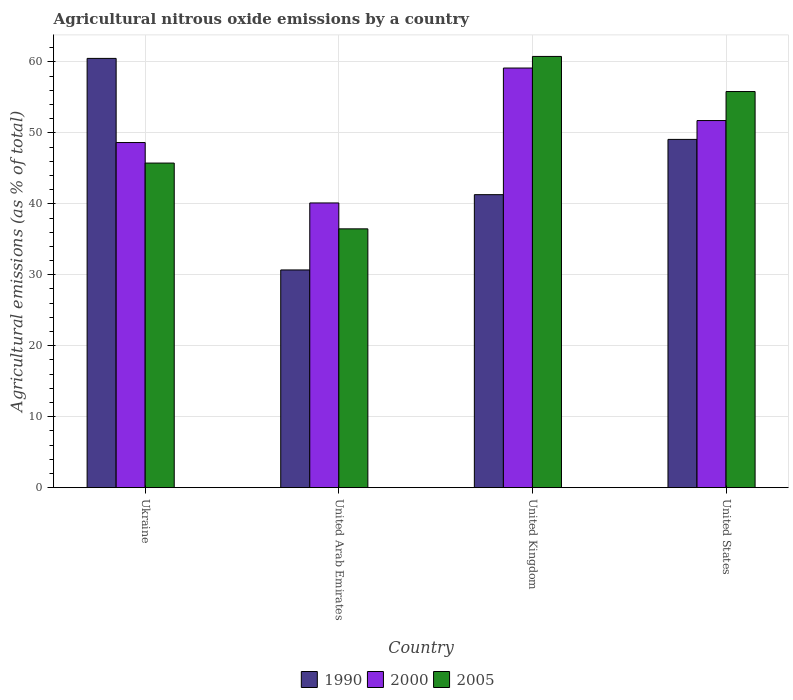How many different coloured bars are there?
Give a very brief answer. 3. How many groups of bars are there?
Keep it short and to the point. 4. Are the number of bars on each tick of the X-axis equal?
Give a very brief answer. Yes. What is the label of the 2nd group of bars from the left?
Offer a terse response. United Arab Emirates. What is the amount of agricultural nitrous oxide emitted in 2005 in United States?
Your response must be concise. 55.83. Across all countries, what is the maximum amount of agricultural nitrous oxide emitted in 1990?
Ensure brevity in your answer.  60.5. Across all countries, what is the minimum amount of agricultural nitrous oxide emitted in 2005?
Keep it short and to the point. 36.47. In which country was the amount of agricultural nitrous oxide emitted in 1990 minimum?
Give a very brief answer. United Arab Emirates. What is the total amount of agricultural nitrous oxide emitted in 2000 in the graph?
Ensure brevity in your answer.  199.64. What is the difference between the amount of agricultural nitrous oxide emitted in 2005 in Ukraine and that in United Kingdom?
Offer a terse response. -15.03. What is the difference between the amount of agricultural nitrous oxide emitted in 1990 in United Kingdom and the amount of agricultural nitrous oxide emitted in 2000 in United States?
Make the answer very short. -10.45. What is the average amount of agricultural nitrous oxide emitted in 1990 per country?
Your answer should be very brief. 45.39. What is the difference between the amount of agricultural nitrous oxide emitted of/in 2000 and amount of agricultural nitrous oxide emitted of/in 2005 in United States?
Keep it short and to the point. -4.09. In how many countries, is the amount of agricultural nitrous oxide emitted in 2005 greater than 6 %?
Your answer should be compact. 4. What is the ratio of the amount of agricultural nitrous oxide emitted in 1990 in Ukraine to that in United States?
Give a very brief answer. 1.23. What is the difference between the highest and the second highest amount of agricultural nitrous oxide emitted in 2000?
Give a very brief answer. -3.1. What is the difference between the highest and the lowest amount of agricultural nitrous oxide emitted in 2005?
Ensure brevity in your answer.  24.3. In how many countries, is the amount of agricultural nitrous oxide emitted in 2000 greater than the average amount of agricultural nitrous oxide emitted in 2000 taken over all countries?
Give a very brief answer. 2. Is the sum of the amount of agricultural nitrous oxide emitted in 2000 in Ukraine and United Arab Emirates greater than the maximum amount of agricultural nitrous oxide emitted in 2005 across all countries?
Make the answer very short. Yes. What does the 3rd bar from the left in United Kingdom represents?
Your response must be concise. 2005. Is it the case that in every country, the sum of the amount of agricultural nitrous oxide emitted in 1990 and amount of agricultural nitrous oxide emitted in 2000 is greater than the amount of agricultural nitrous oxide emitted in 2005?
Provide a short and direct response. Yes. How many bars are there?
Your answer should be compact. 12. How many countries are there in the graph?
Give a very brief answer. 4. What is the difference between two consecutive major ticks on the Y-axis?
Offer a very short reply. 10. Does the graph contain any zero values?
Provide a short and direct response. No. Does the graph contain grids?
Provide a succinct answer. Yes. Where does the legend appear in the graph?
Make the answer very short. Bottom center. How many legend labels are there?
Your answer should be very brief. 3. What is the title of the graph?
Offer a very short reply. Agricultural nitrous oxide emissions by a country. Does "2003" appear as one of the legend labels in the graph?
Provide a succinct answer. No. What is the label or title of the X-axis?
Keep it short and to the point. Country. What is the label or title of the Y-axis?
Offer a very short reply. Agricultural emissions (as % of total). What is the Agricultural emissions (as % of total) of 1990 in Ukraine?
Ensure brevity in your answer.  60.5. What is the Agricultural emissions (as % of total) of 2000 in Ukraine?
Keep it short and to the point. 48.64. What is the Agricultural emissions (as % of total) in 2005 in Ukraine?
Your response must be concise. 45.75. What is the Agricultural emissions (as % of total) in 1990 in United Arab Emirates?
Keep it short and to the point. 30.68. What is the Agricultural emissions (as % of total) of 2000 in United Arab Emirates?
Keep it short and to the point. 40.12. What is the Agricultural emissions (as % of total) of 2005 in United Arab Emirates?
Make the answer very short. 36.47. What is the Agricultural emissions (as % of total) of 1990 in United Kingdom?
Make the answer very short. 41.29. What is the Agricultural emissions (as % of total) in 2000 in United Kingdom?
Offer a very short reply. 59.14. What is the Agricultural emissions (as % of total) in 2005 in United Kingdom?
Provide a succinct answer. 60.77. What is the Agricultural emissions (as % of total) in 1990 in United States?
Your answer should be compact. 49.08. What is the Agricultural emissions (as % of total) of 2000 in United States?
Give a very brief answer. 51.74. What is the Agricultural emissions (as % of total) of 2005 in United States?
Your answer should be very brief. 55.83. Across all countries, what is the maximum Agricultural emissions (as % of total) in 1990?
Offer a terse response. 60.5. Across all countries, what is the maximum Agricultural emissions (as % of total) in 2000?
Provide a short and direct response. 59.14. Across all countries, what is the maximum Agricultural emissions (as % of total) in 2005?
Provide a short and direct response. 60.77. Across all countries, what is the minimum Agricultural emissions (as % of total) of 1990?
Provide a succinct answer. 30.68. Across all countries, what is the minimum Agricultural emissions (as % of total) in 2000?
Keep it short and to the point. 40.12. Across all countries, what is the minimum Agricultural emissions (as % of total) of 2005?
Keep it short and to the point. 36.47. What is the total Agricultural emissions (as % of total) of 1990 in the graph?
Provide a short and direct response. 181.55. What is the total Agricultural emissions (as % of total) of 2000 in the graph?
Your answer should be compact. 199.64. What is the total Agricultural emissions (as % of total) of 2005 in the graph?
Make the answer very short. 198.82. What is the difference between the Agricultural emissions (as % of total) in 1990 in Ukraine and that in United Arab Emirates?
Make the answer very short. 29.81. What is the difference between the Agricultural emissions (as % of total) of 2000 in Ukraine and that in United Arab Emirates?
Your answer should be compact. 8.51. What is the difference between the Agricultural emissions (as % of total) in 2005 in Ukraine and that in United Arab Emirates?
Your answer should be compact. 9.27. What is the difference between the Agricultural emissions (as % of total) in 1990 in Ukraine and that in United Kingdom?
Provide a succinct answer. 19.2. What is the difference between the Agricultural emissions (as % of total) in 2000 in Ukraine and that in United Kingdom?
Give a very brief answer. -10.5. What is the difference between the Agricultural emissions (as % of total) in 2005 in Ukraine and that in United Kingdom?
Give a very brief answer. -15.03. What is the difference between the Agricultural emissions (as % of total) in 1990 in Ukraine and that in United States?
Provide a succinct answer. 11.42. What is the difference between the Agricultural emissions (as % of total) in 2000 in Ukraine and that in United States?
Offer a terse response. -3.1. What is the difference between the Agricultural emissions (as % of total) of 2005 in Ukraine and that in United States?
Keep it short and to the point. -10.08. What is the difference between the Agricultural emissions (as % of total) in 1990 in United Arab Emirates and that in United Kingdom?
Give a very brief answer. -10.61. What is the difference between the Agricultural emissions (as % of total) in 2000 in United Arab Emirates and that in United Kingdom?
Ensure brevity in your answer.  -19.01. What is the difference between the Agricultural emissions (as % of total) in 2005 in United Arab Emirates and that in United Kingdom?
Offer a very short reply. -24.3. What is the difference between the Agricultural emissions (as % of total) in 1990 in United Arab Emirates and that in United States?
Your response must be concise. -18.4. What is the difference between the Agricultural emissions (as % of total) in 2000 in United Arab Emirates and that in United States?
Your response must be concise. -11.61. What is the difference between the Agricultural emissions (as % of total) of 2005 in United Arab Emirates and that in United States?
Provide a short and direct response. -19.35. What is the difference between the Agricultural emissions (as % of total) of 1990 in United Kingdom and that in United States?
Offer a terse response. -7.79. What is the difference between the Agricultural emissions (as % of total) of 2000 in United Kingdom and that in United States?
Provide a succinct answer. 7.4. What is the difference between the Agricultural emissions (as % of total) of 2005 in United Kingdom and that in United States?
Offer a terse response. 4.95. What is the difference between the Agricultural emissions (as % of total) in 1990 in Ukraine and the Agricultural emissions (as % of total) in 2000 in United Arab Emirates?
Your response must be concise. 20.37. What is the difference between the Agricultural emissions (as % of total) of 1990 in Ukraine and the Agricultural emissions (as % of total) of 2005 in United Arab Emirates?
Keep it short and to the point. 24.02. What is the difference between the Agricultural emissions (as % of total) of 2000 in Ukraine and the Agricultural emissions (as % of total) of 2005 in United Arab Emirates?
Give a very brief answer. 12.16. What is the difference between the Agricultural emissions (as % of total) of 1990 in Ukraine and the Agricultural emissions (as % of total) of 2000 in United Kingdom?
Offer a terse response. 1.36. What is the difference between the Agricultural emissions (as % of total) in 1990 in Ukraine and the Agricultural emissions (as % of total) in 2005 in United Kingdom?
Keep it short and to the point. -0.28. What is the difference between the Agricultural emissions (as % of total) in 2000 in Ukraine and the Agricultural emissions (as % of total) in 2005 in United Kingdom?
Provide a succinct answer. -12.14. What is the difference between the Agricultural emissions (as % of total) of 1990 in Ukraine and the Agricultural emissions (as % of total) of 2000 in United States?
Your answer should be compact. 8.76. What is the difference between the Agricultural emissions (as % of total) of 1990 in Ukraine and the Agricultural emissions (as % of total) of 2005 in United States?
Your response must be concise. 4.67. What is the difference between the Agricultural emissions (as % of total) in 2000 in Ukraine and the Agricultural emissions (as % of total) in 2005 in United States?
Your answer should be very brief. -7.19. What is the difference between the Agricultural emissions (as % of total) in 1990 in United Arab Emirates and the Agricultural emissions (as % of total) in 2000 in United Kingdom?
Provide a short and direct response. -28.46. What is the difference between the Agricultural emissions (as % of total) of 1990 in United Arab Emirates and the Agricultural emissions (as % of total) of 2005 in United Kingdom?
Your answer should be very brief. -30.09. What is the difference between the Agricultural emissions (as % of total) of 2000 in United Arab Emirates and the Agricultural emissions (as % of total) of 2005 in United Kingdom?
Your answer should be compact. -20.65. What is the difference between the Agricultural emissions (as % of total) of 1990 in United Arab Emirates and the Agricultural emissions (as % of total) of 2000 in United States?
Ensure brevity in your answer.  -21.05. What is the difference between the Agricultural emissions (as % of total) of 1990 in United Arab Emirates and the Agricultural emissions (as % of total) of 2005 in United States?
Provide a succinct answer. -25.14. What is the difference between the Agricultural emissions (as % of total) of 2000 in United Arab Emirates and the Agricultural emissions (as % of total) of 2005 in United States?
Offer a very short reply. -15.7. What is the difference between the Agricultural emissions (as % of total) in 1990 in United Kingdom and the Agricultural emissions (as % of total) in 2000 in United States?
Your response must be concise. -10.45. What is the difference between the Agricultural emissions (as % of total) of 1990 in United Kingdom and the Agricultural emissions (as % of total) of 2005 in United States?
Provide a short and direct response. -14.53. What is the difference between the Agricultural emissions (as % of total) in 2000 in United Kingdom and the Agricultural emissions (as % of total) in 2005 in United States?
Offer a very short reply. 3.31. What is the average Agricultural emissions (as % of total) in 1990 per country?
Provide a succinct answer. 45.39. What is the average Agricultural emissions (as % of total) in 2000 per country?
Make the answer very short. 49.91. What is the average Agricultural emissions (as % of total) of 2005 per country?
Provide a short and direct response. 49.7. What is the difference between the Agricultural emissions (as % of total) of 1990 and Agricultural emissions (as % of total) of 2000 in Ukraine?
Your answer should be very brief. 11.86. What is the difference between the Agricultural emissions (as % of total) of 1990 and Agricultural emissions (as % of total) of 2005 in Ukraine?
Your answer should be very brief. 14.75. What is the difference between the Agricultural emissions (as % of total) of 2000 and Agricultural emissions (as % of total) of 2005 in Ukraine?
Your answer should be compact. 2.89. What is the difference between the Agricultural emissions (as % of total) of 1990 and Agricultural emissions (as % of total) of 2000 in United Arab Emirates?
Keep it short and to the point. -9.44. What is the difference between the Agricultural emissions (as % of total) in 1990 and Agricultural emissions (as % of total) in 2005 in United Arab Emirates?
Offer a terse response. -5.79. What is the difference between the Agricultural emissions (as % of total) in 2000 and Agricultural emissions (as % of total) in 2005 in United Arab Emirates?
Offer a terse response. 3.65. What is the difference between the Agricultural emissions (as % of total) in 1990 and Agricultural emissions (as % of total) in 2000 in United Kingdom?
Keep it short and to the point. -17.85. What is the difference between the Agricultural emissions (as % of total) in 1990 and Agricultural emissions (as % of total) in 2005 in United Kingdom?
Make the answer very short. -19.48. What is the difference between the Agricultural emissions (as % of total) in 2000 and Agricultural emissions (as % of total) in 2005 in United Kingdom?
Offer a very short reply. -1.63. What is the difference between the Agricultural emissions (as % of total) in 1990 and Agricultural emissions (as % of total) in 2000 in United States?
Make the answer very short. -2.66. What is the difference between the Agricultural emissions (as % of total) of 1990 and Agricultural emissions (as % of total) of 2005 in United States?
Give a very brief answer. -6.75. What is the difference between the Agricultural emissions (as % of total) of 2000 and Agricultural emissions (as % of total) of 2005 in United States?
Make the answer very short. -4.09. What is the ratio of the Agricultural emissions (as % of total) in 1990 in Ukraine to that in United Arab Emirates?
Provide a short and direct response. 1.97. What is the ratio of the Agricultural emissions (as % of total) in 2000 in Ukraine to that in United Arab Emirates?
Your answer should be very brief. 1.21. What is the ratio of the Agricultural emissions (as % of total) of 2005 in Ukraine to that in United Arab Emirates?
Your response must be concise. 1.25. What is the ratio of the Agricultural emissions (as % of total) in 1990 in Ukraine to that in United Kingdom?
Your answer should be compact. 1.47. What is the ratio of the Agricultural emissions (as % of total) of 2000 in Ukraine to that in United Kingdom?
Make the answer very short. 0.82. What is the ratio of the Agricultural emissions (as % of total) in 2005 in Ukraine to that in United Kingdom?
Your answer should be compact. 0.75. What is the ratio of the Agricultural emissions (as % of total) of 1990 in Ukraine to that in United States?
Ensure brevity in your answer.  1.23. What is the ratio of the Agricultural emissions (as % of total) in 2000 in Ukraine to that in United States?
Provide a short and direct response. 0.94. What is the ratio of the Agricultural emissions (as % of total) in 2005 in Ukraine to that in United States?
Your response must be concise. 0.82. What is the ratio of the Agricultural emissions (as % of total) in 1990 in United Arab Emirates to that in United Kingdom?
Your response must be concise. 0.74. What is the ratio of the Agricultural emissions (as % of total) in 2000 in United Arab Emirates to that in United Kingdom?
Your answer should be very brief. 0.68. What is the ratio of the Agricultural emissions (as % of total) in 2005 in United Arab Emirates to that in United Kingdom?
Offer a very short reply. 0.6. What is the ratio of the Agricultural emissions (as % of total) of 1990 in United Arab Emirates to that in United States?
Give a very brief answer. 0.63. What is the ratio of the Agricultural emissions (as % of total) of 2000 in United Arab Emirates to that in United States?
Offer a very short reply. 0.78. What is the ratio of the Agricultural emissions (as % of total) in 2005 in United Arab Emirates to that in United States?
Ensure brevity in your answer.  0.65. What is the ratio of the Agricultural emissions (as % of total) in 1990 in United Kingdom to that in United States?
Make the answer very short. 0.84. What is the ratio of the Agricultural emissions (as % of total) in 2000 in United Kingdom to that in United States?
Provide a succinct answer. 1.14. What is the ratio of the Agricultural emissions (as % of total) of 2005 in United Kingdom to that in United States?
Your response must be concise. 1.09. What is the difference between the highest and the second highest Agricultural emissions (as % of total) in 1990?
Keep it short and to the point. 11.42. What is the difference between the highest and the second highest Agricultural emissions (as % of total) in 2000?
Provide a short and direct response. 7.4. What is the difference between the highest and the second highest Agricultural emissions (as % of total) of 2005?
Offer a very short reply. 4.95. What is the difference between the highest and the lowest Agricultural emissions (as % of total) in 1990?
Your response must be concise. 29.81. What is the difference between the highest and the lowest Agricultural emissions (as % of total) in 2000?
Your answer should be very brief. 19.01. What is the difference between the highest and the lowest Agricultural emissions (as % of total) of 2005?
Offer a very short reply. 24.3. 